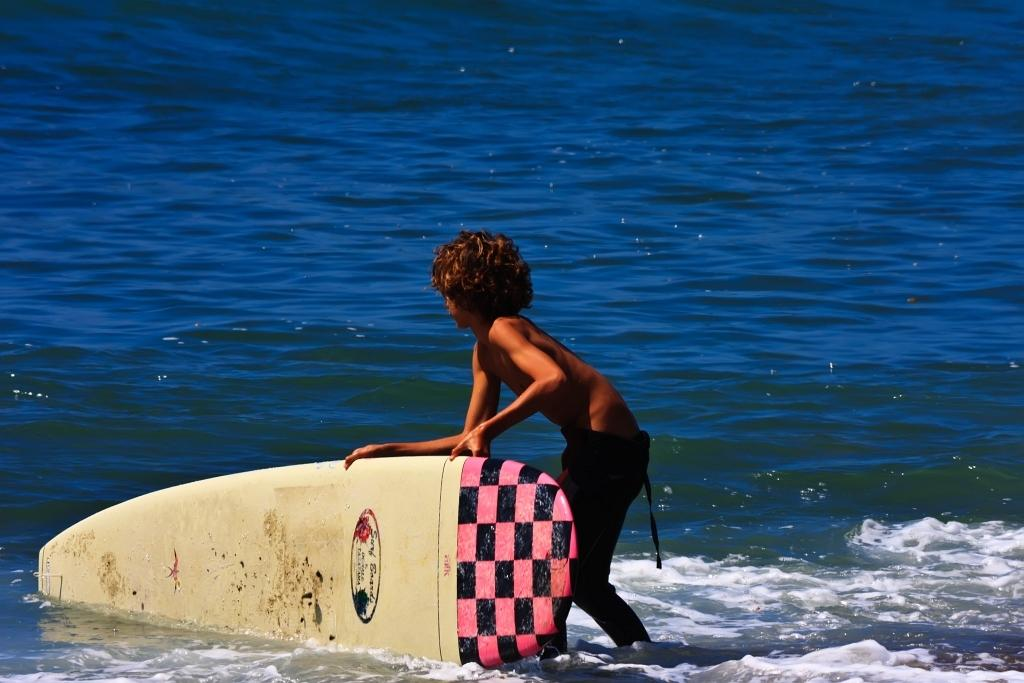What is the main subject of the image? The main subject of the image is a kid. What is the kid holding in the image? The kid is holding a surfing board. What can be seen in the background of the image? There is water visible in the image. What type of meal is the kid preparing in the image? There is no indication in the image that the kid is preparing a meal, as they are holding a surfing board and standing in water. 